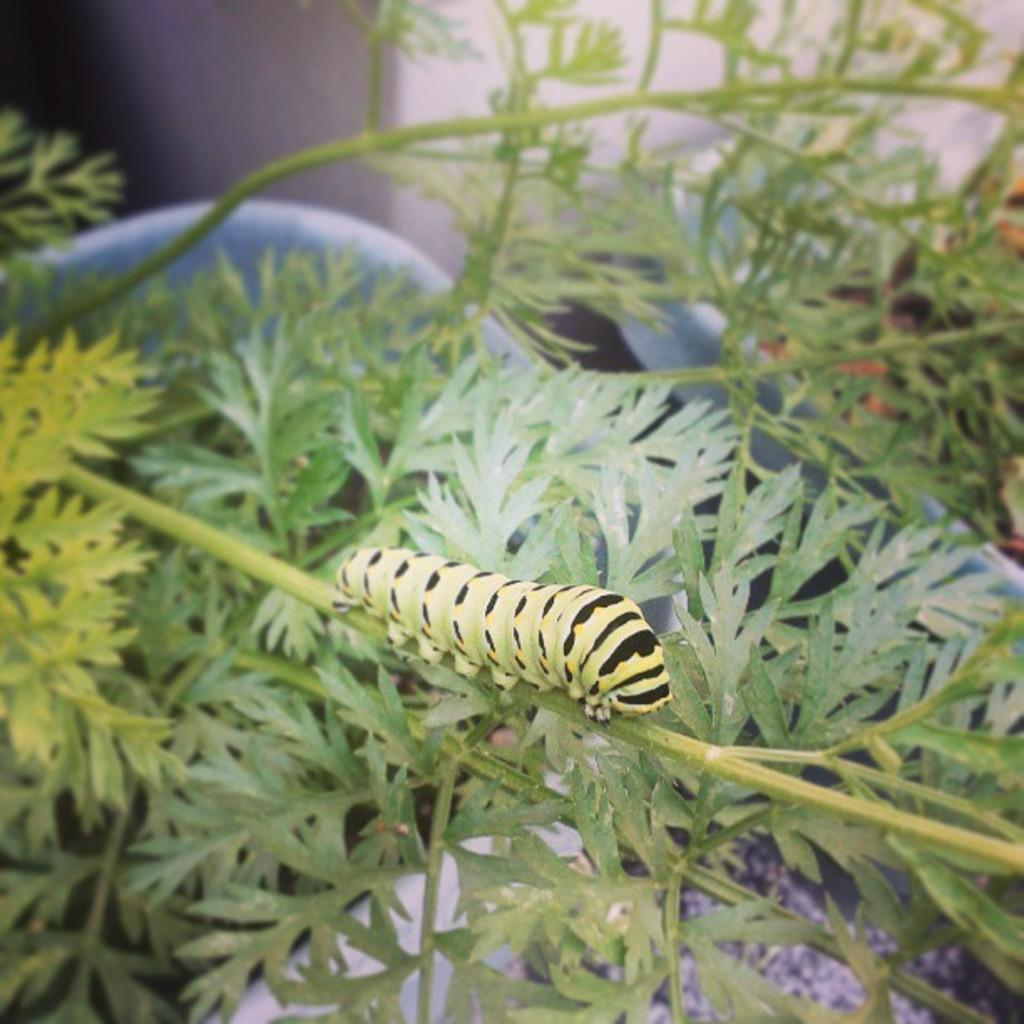What type of creature is in the image? There is an insect in the image. What colors can be seen on the insect? The insect has green and black colors. Where is the insect located in the image? The insect is on a plant. What is the color of the plants in the image? The plants in the image are green. What shape is the house in the image? There is no house present in the image; it features an insect on a plant. How many sides does the square have in the image? There is no square present in the image. 